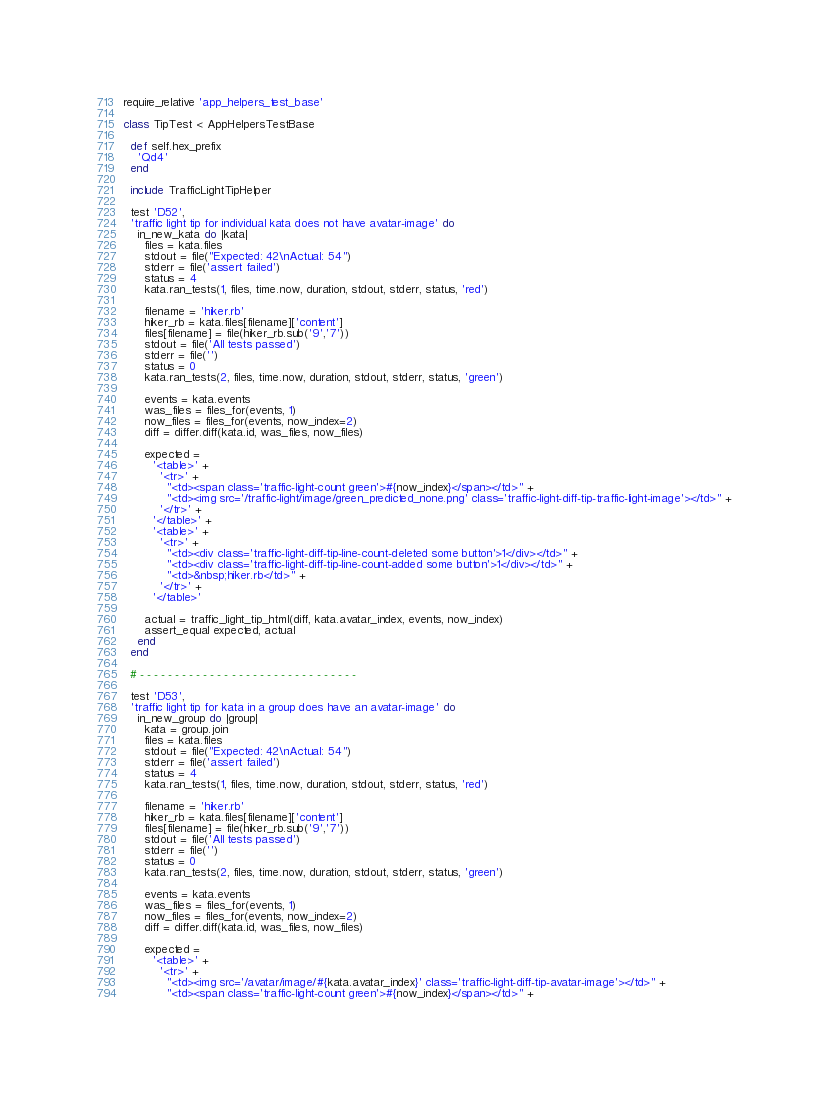Convert code to text. <code><loc_0><loc_0><loc_500><loc_500><_Ruby_>require_relative 'app_helpers_test_base'

class TipTest < AppHelpersTestBase

  def self.hex_prefix
    'Qd4'
  end

  include TrafficLightTipHelper

  test 'D52',
  'traffic light tip for individual kata does not have avatar-image' do
    in_new_kata do |kata|
      files = kata.files
      stdout = file("Expected: 42\nActual: 54")
      stderr = file('assert failed')
      status = 4
      kata.ran_tests(1, files, time.now, duration, stdout, stderr, status, 'red')

      filename = 'hiker.rb'
      hiker_rb = kata.files[filename]['content']
      files[filename] = file(hiker_rb.sub('9','7'))
      stdout = file('All tests passed')
      stderr = file('')
      status = 0
      kata.ran_tests(2, files, time.now, duration, stdout, stderr, status, 'green')

      events = kata.events
      was_files = files_for(events, 1)
      now_files = files_for(events, now_index=2)
      diff = differ.diff(kata.id, was_files, now_files)

      expected =
        '<table>' +
          '<tr>' +
            "<td><span class='traffic-light-count green'>#{now_index}</span></td>" +
            "<td><img src='/traffic-light/image/green_predicted_none.png' class='traffic-light-diff-tip-traffic-light-image'></td>" +
          '</tr>' +
        '</table>' +
        '<table>' +
          '<tr>' +
            "<td><div class='traffic-light-diff-tip-line-count-deleted some button'>1</div></td>" +
            "<td><div class='traffic-light-diff-tip-line-count-added some button'>1</div></td>" +
            "<td>&nbsp;hiker.rb</td>" +
          '</tr>' +
        '</table>'

      actual = traffic_light_tip_html(diff, kata.avatar_index, events, now_index)
      assert_equal expected, actual
    end
  end

  # - - - - - - - - - - - - - - - - - - - - - - - - - - - - - - -

  test 'D53',
  'traffic light tip for kata in a group does have an avatar-image' do
    in_new_group do |group|
      kata = group.join
      files = kata.files
      stdout = file("Expected: 42\nActual: 54")
      stderr = file('assert failed')
      status = 4
      kata.ran_tests(1, files, time.now, duration, stdout, stderr, status, 'red')

      filename = 'hiker.rb'
      hiker_rb = kata.files[filename]['content']
      files[filename] = file(hiker_rb.sub('9','7'))
      stdout = file('All tests passed')
      stderr = file('')
      status = 0
      kata.ran_tests(2, files, time.now, duration, stdout, stderr, status, 'green')

      events = kata.events
      was_files = files_for(events, 1)
      now_files = files_for(events, now_index=2)
      diff = differ.diff(kata.id, was_files, now_files)

      expected =
        '<table>' +
          '<tr>' +
            "<td><img src='/avatar/image/#{kata.avatar_index}' class='traffic-light-diff-tip-avatar-image'></td>" +
            "<td><span class='traffic-light-count green'>#{now_index}</span></td>" +</code> 